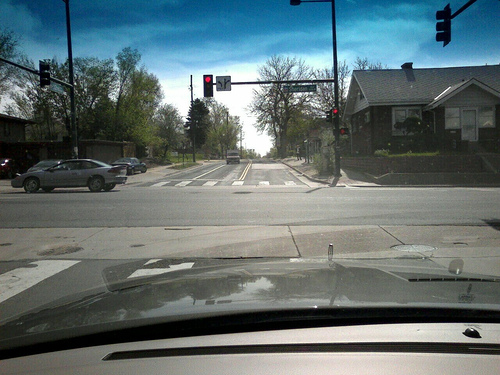Is the area urban or suburban? Based on the single-family homes and the layout of the intersection, the area appears to be suburban with a residential environment rather than a dense urban setting. 